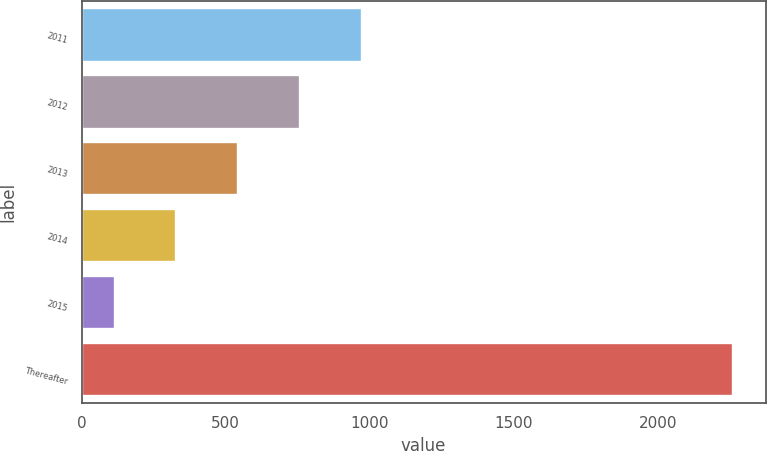Convert chart. <chart><loc_0><loc_0><loc_500><loc_500><bar_chart><fcel>2011<fcel>2012<fcel>2013<fcel>2014<fcel>2015<fcel>Thereafter<nl><fcel>972.76<fcel>758.17<fcel>543.58<fcel>328.99<fcel>114.4<fcel>2260.3<nl></chart> 